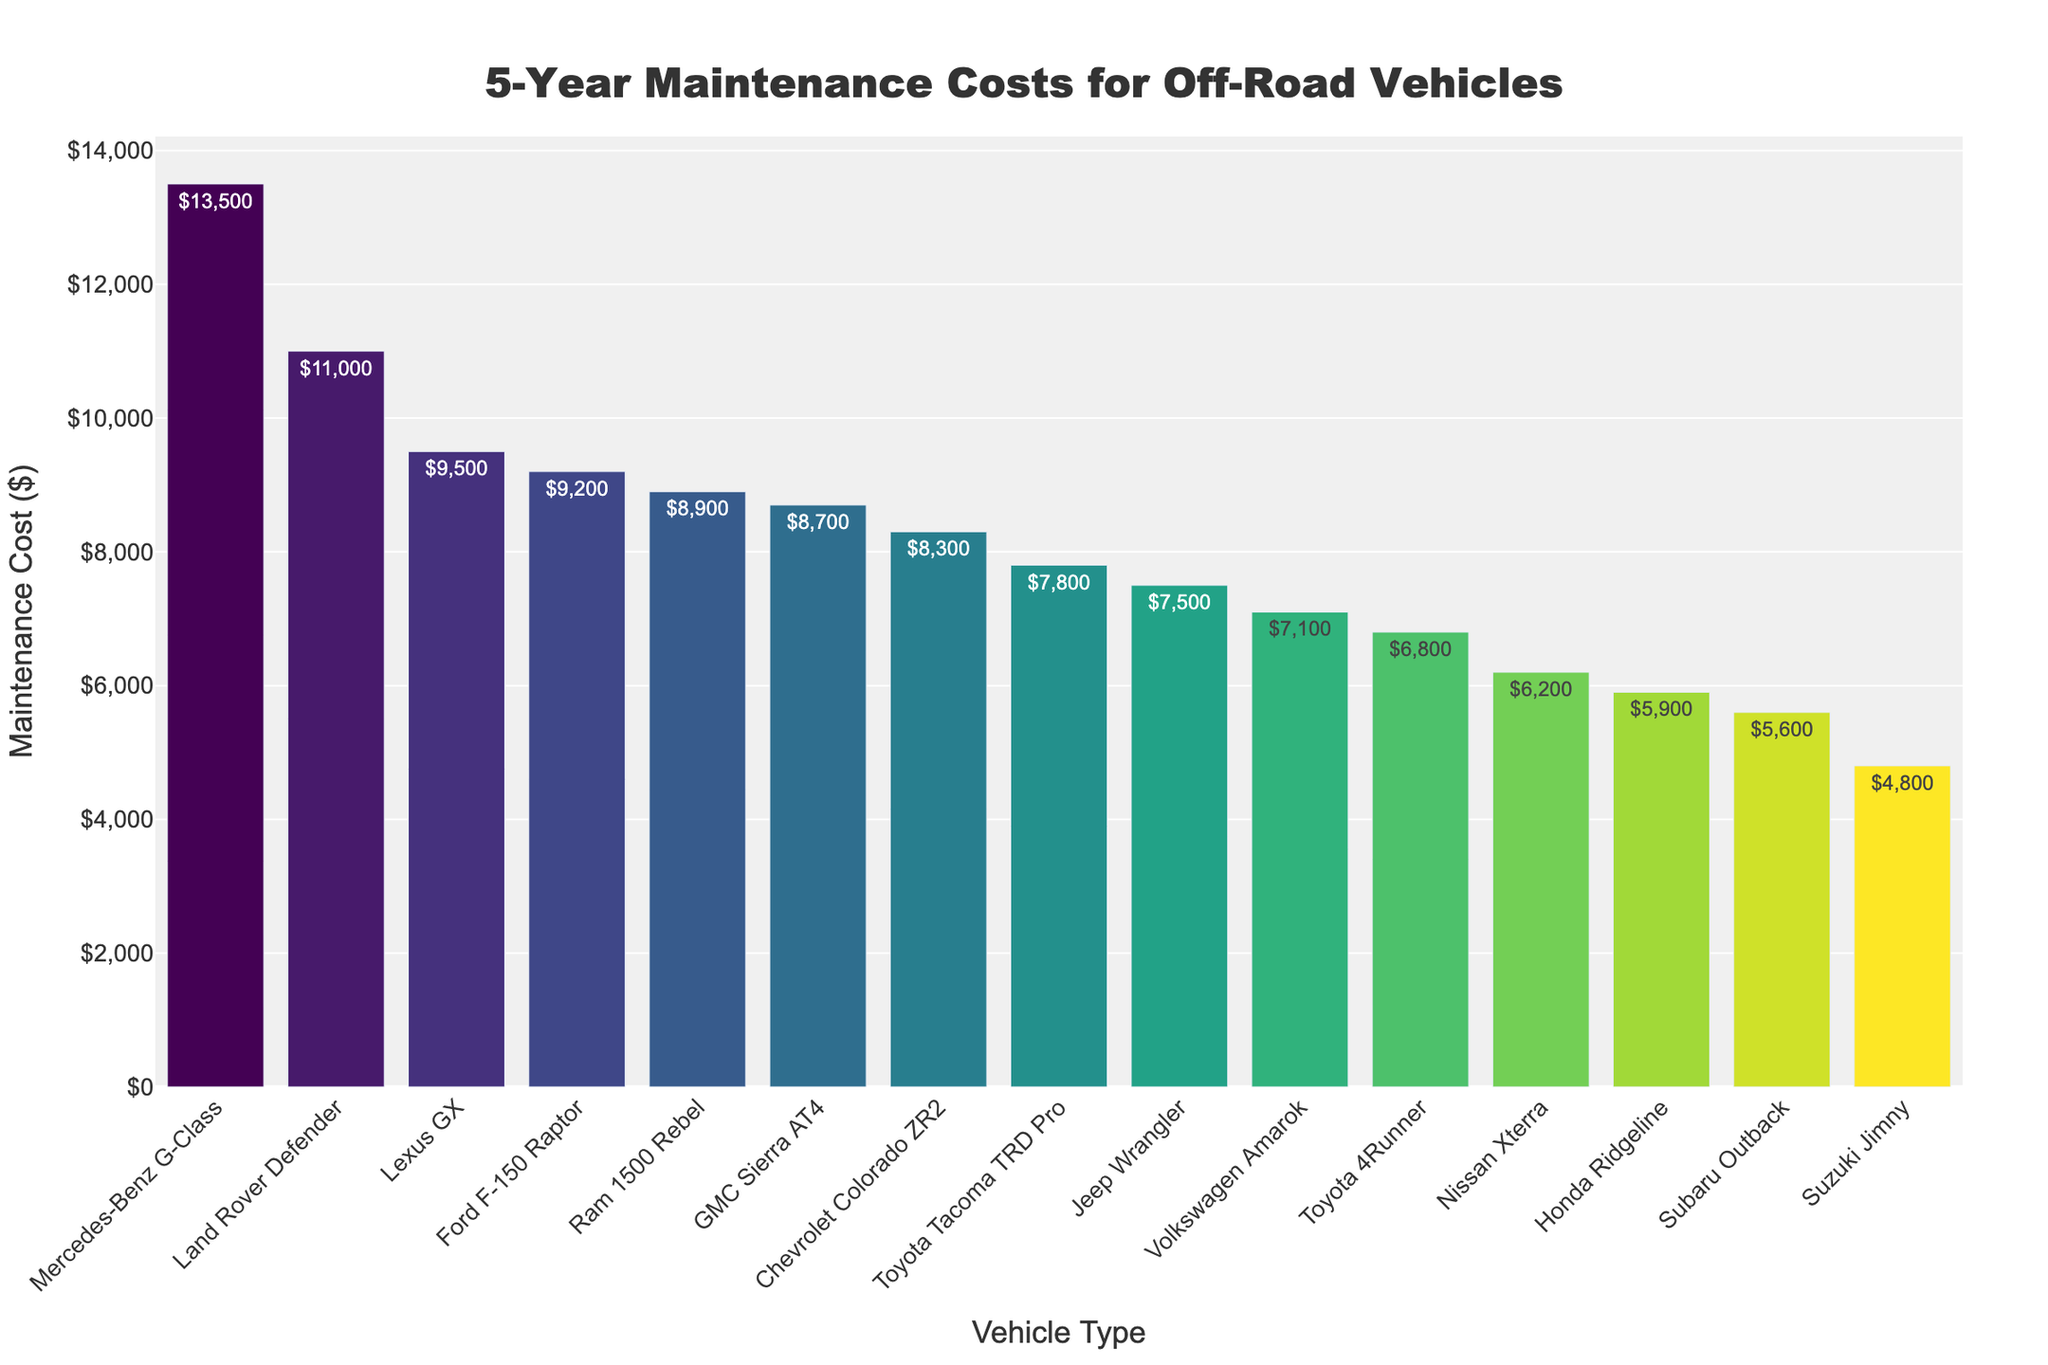Which vehicle has the highest 5-year maintenance cost? The highest bar on the chart represents the Mercedes-Benz G-Class with the maintenance cost labeled next to it.
Answer: Mercedes-Benz G-Class What is the difference in 5-year maintenance cost between the Land Rover Defender and the Suzuki Jimny? The bar heights and labels show $11,000 for the Land Rover Defender and $4,800 for the Suzuki Jimny. Subtract $4,800 from $11,000 to find the difference.
Answer: $6,200 Which vehicle types have a 5-year maintenance cost greater than $9,000? The bars higher than $9,000 are easily identifiable. The vehicles above this mark are the Ford F-150 Raptor, Land Rover Defender, Lexus GX, and Mercedes-Benz G-Class.
Answer: Ford F-150 Raptor, Land Rover Defender, Lexus GX, Mercedes-Benz G-Class What is the total 5-year maintenance cost for Toyota's off-road vehicles listed (4Runner and Tacoma TRD Pro)? Add the 5-year maintenance costs for Toyota 4Runner ($6,800) and Toyota Tacoma TRD Pro ($7,800). The sum is $6,800 + $7,800.
Answer: $14,600 What is the average 5-year maintenance cost for vehicles with costs listed below $7,000? Identify vehicles with costs below $7,000: Subaru Outback ($5,600), Nissan Xterra ($6,200), Honda Ridgeline ($5,900), Suzuki Jimny ($4,800), and Volkswagen Amarok ($7,100). Add these and divide by the number of vehicles: ($5,600 + $6,200 + $5,900 + $4,800 + $7,100) / 5.
Answer: $5,920 Which vehicle has a maintenance cost closest to $8,000? Examine the bar heights carefully around the $8,000 mark and find the one nearest. The Toyota Tacoma TRD Pro has a road vehicle cost of $7,800, closest to $8,000.
Answer: Toyota Tacoma TRD Pro How much more does the Mercedes-Benz G-Class cost in maintenance over 5 years compared to the GMC Sierra AT4? Find the maintenance costs for both vehicles: $13,500 for Mercedes-Benz G-Class and $8,700 for GMC Sierra AT4. Subtract $8,700 from $13,500.
Answer: $4,800 Which vehicle type has the lowest 5-year maintenance cost and what is that cost? The shortest bar corresponds to the Suzuki Jimny with the cost labeled as $4,800.
Answer: Suzuki Jimny, $4,800 